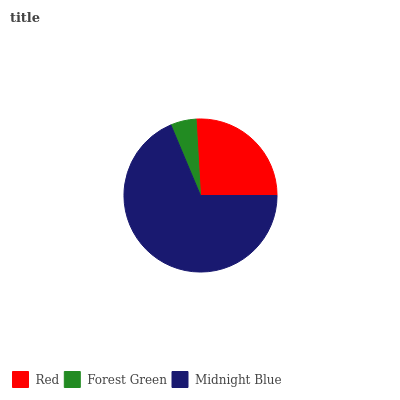Is Forest Green the minimum?
Answer yes or no. Yes. Is Midnight Blue the maximum?
Answer yes or no. Yes. Is Midnight Blue the minimum?
Answer yes or no. No. Is Forest Green the maximum?
Answer yes or no. No. Is Midnight Blue greater than Forest Green?
Answer yes or no. Yes. Is Forest Green less than Midnight Blue?
Answer yes or no. Yes. Is Forest Green greater than Midnight Blue?
Answer yes or no. No. Is Midnight Blue less than Forest Green?
Answer yes or no. No. Is Red the high median?
Answer yes or no. Yes. Is Red the low median?
Answer yes or no. Yes. Is Midnight Blue the high median?
Answer yes or no. No. Is Midnight Blue the low median?
Answer yes or no. No. 